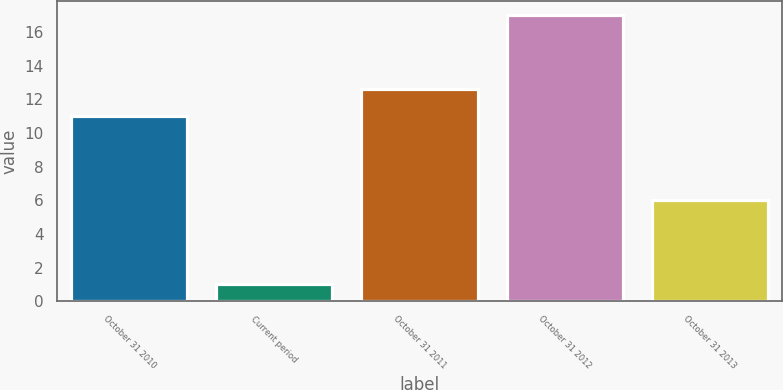<chart> <loc_0><loc_0><loc_500><loc_500><bar_chart><fcel>October 31 2010<fcel>Current period<fcel>October 31 2011<fcel>October 31 2012<fcel>October 31 2013<nl><fcel>11<fcel>1<fcel>12.6<fcel>17<fcel>6<nl></chart> 